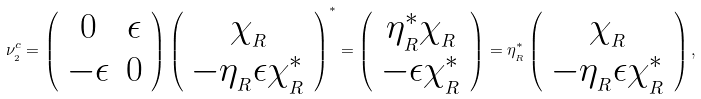Convert formula to latex. <formula><loc_0><loc_0><loc_500><loc_500>\nu _ { _ { 2 } } ^ { c } = \left ( \begin{array} { c c } 0 & \epsilon \\ - \epsilon & 0 \end{array} \right ) \left ( \begin{array} { c } \chi _ { _ { R } } \\ - \eta _ { _ { R } } \epsilon \chi ^ { * } _ { _ { R } } \end{array} \right ) ^ { * } = \left ( \begin{array} { c } \eta _ { _ { R } } ^ { * } \chi _ { _ { R } } \\ - \epsilon \chi ^ { * } _ { _ { R } } \end{array} \right ) = \eta _ { _ { R } } ^ { * } \left ( \begin{array} { c } \chi _ { _ { R } } \\ - \eta _ { _ { R } } \epsilon \chi _ { _ { R } } ^ { * } \end{array} \right ) ,</formula> 